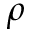<formula> <loc_0><loc_0><loc_500><loc_500>\rho</formula> 